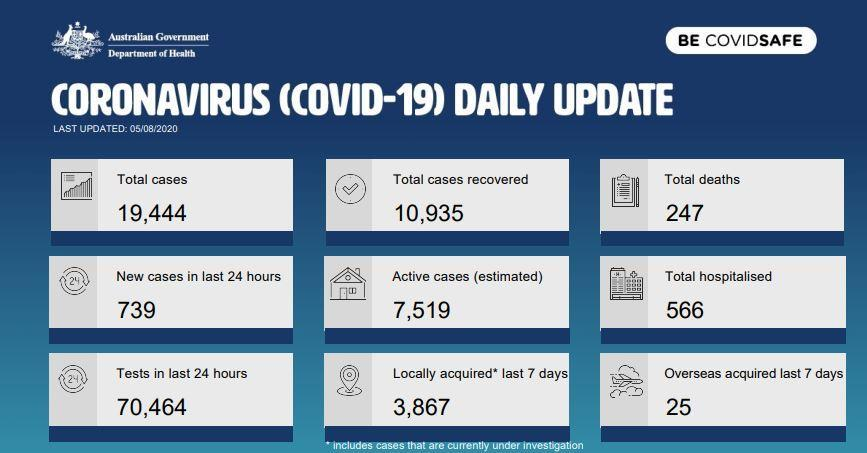What is the total deaths as of 5/8/2020?
Answer the question with a short phrase. 247 What is the total number of recovered cases? 10,935 What is the total number of people hospitalised? 566 What is the number of overseas acquired cases in the past week? 25 What is the number of tests in last 24 hours? 70,464 